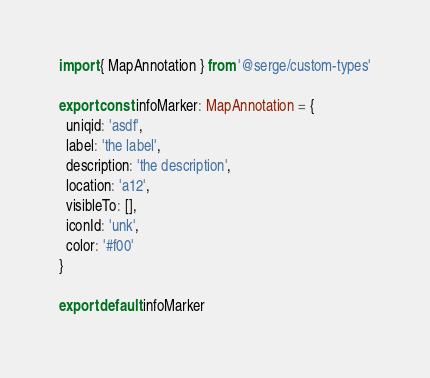<code> <loc_0><loc_0><loc_500><loc_500><_TypeScript_>import { MapAnnotation } from '@serge/custom-types'

export const infoMarker: MapAnnotation = {
  uniqid: 'asdf',
  label: 'the label',
  description: 'the description',
  location: 'a12',
  visibleTo: [],
  iconId: 'unk',
  color: '#f00'
}

export default infoMarker</code> 